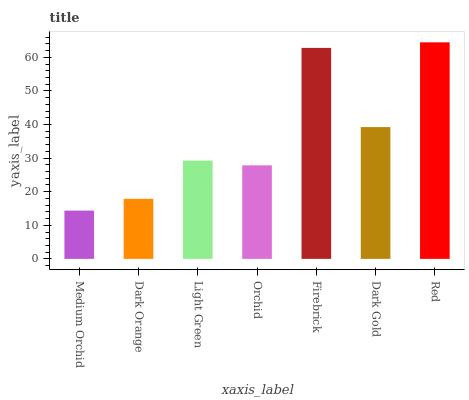Is Dark Orange the minimum?
Answer yes or no. No. Is Dark Orange the maximum?
Answer yes or no. No. Is Dark Orange greater than Medium Orchid?
Answer yes or no. Yes. Is Medium Orchid less than Dark Orange?
Answer yes or no. Yes. Is Medium Orchid greater than Dark Orange?
Answer yes or no. No. Is Dark Orange less than Medium Orchid?
Answer yes or no. No. Is Light Green the high median?
Answer yes or no. Yes. Is Light Green the low median?
Answer yes or no. Yes. Is Medium Orchid the high median?
Answer yes or no. No. Is Dark Gold the low median?
Answer yes or no. No. 